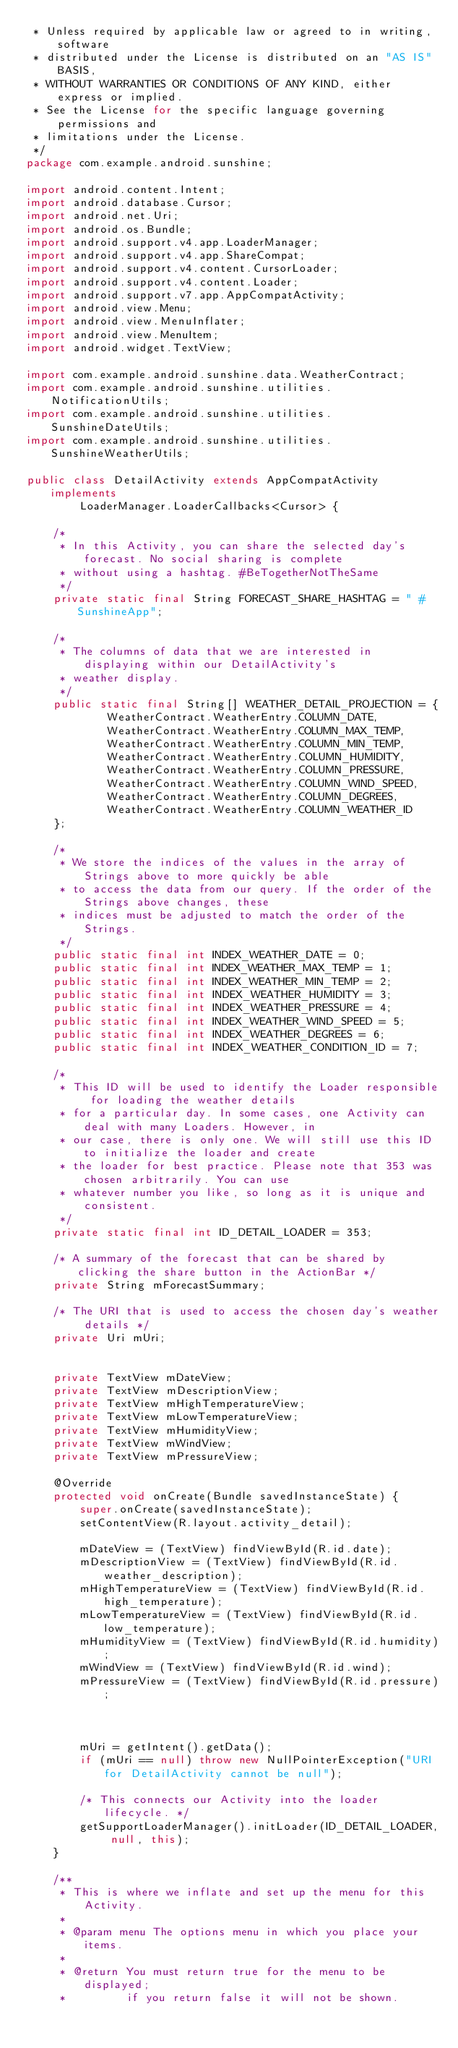<code> <loc_0><loc_0><loc_500><loc_500><_Java_> * Unless required by applicable law or agreed to in writing, software
 * distributed under the License is distributed on an "AS IS" BASIS,
 * WITHOUT WARRANTIES OR CONDITIONS OF ANY KIND, either express or implied.
 * See the License for the specific language governing permissions and
 * limitations under the License.
 */
package com.example.android.sunshine;

import android.content.Intent;
import android.database.Cursor;
import android.net.Uri;
import android.os.Bundle;
import android.support.v4.app.LoaderManager;
import android.support.v4.app.ShareCompat;
import android.support.v4.content.CursorLoader;
import android.support.v4.content.Loader;
import android.support.v7.app.AppCompatActivity;
import android.view.Menu;
import android.view.MenuInflater;
import android.view.MenuItem;
import android.widget.TextView;

import com.example.android.sunshine.data.WeatherContract;
import com.example.android.sunshine.utilities.NotificationUtils;
import com.example.android.sunshine.utilities.SunshineDateUtils;
import com.example.android.sunshine.utilities.SunshineWeatherUtils;

public class DetailActivity extends AppCompatActivity implements
        LoaderManager.LoaderCallbacks<Cursor> {

    /*
     * In this Activity, you can share the selected day's forecast. No social sharing is complete
     * without using a hashtag. #BeTogetherNotTheSame
     */
    private static final String FORECAST_SHARE_HASHTAG = " #SunshineApp";

    /*
     * The columns of data that we are interested in displaying within our DetailActivity's
     * weather display.
     */
    public static final String[] WEATHER_DETAIL_PROJECTION = {
            WeatherContract.WeatherEntry.COLUMN_DATE,
            WeatherContract.WeatherEntry.COLUMN_MAX_TEMP,
            WeatherContract.WeatherEntry.COLUMN_MIN_TEMP,
            WeatherContract.WeatherEntry.COLUMN_HUMIDITY,
            WeatherContract.WeatherEntry.COLUMN_PRESSURE,
            WeatherContract.WeatherEntry.COLUMN_WIND_SPEED,
            WeatherContract.WeatherEntry.COLUMN_DEGREES,
            WeatherContract.WeatherEntry.COLUMN_WEATHER_ID
    };

    /*
     * We store the indices of the values in the array of Strings above to more quickly be able
     * to access the data from our query. If the order of the Strings above changes, these
     * indices must be adjusted to match the order of the Strings.
     */
    public static final int INDEX_WEATHER_DATE = 0;
    public static final int INDEX_WEATHER_MAX_TEMP = 1;
    public static final int INDEX_WEATHER_MIN_TEMP = 2;
    public static final int INDEX_WEATHER_HUMIDITY = 3;
    public static final int INDEX_WEATHER_PRESSURE = 4;
    public static final int INDEX_WEATHER_WIND_SPEED = 5;
    public static final int INDEX_WEATHER_DEGREES = 6;
    public static final int INDEX_WEATHER_CONDITION_ID = 7;

    /*
     * This ID will be used to identify the Loader responsible for loading the weather details
     * for a particular day. In some cases, one Activity can deal with many Loaders. However, in
     * our case, there is only one. We will still use this ID to initialize the loader and create
     * the loader for best practice. Please note that 353 was chosen arbitrarily. You can use
     * whatever number you like, so long as it is unique and consistent.
     */
    private static final int ID_DETAIL_LOADER = 353;

    /* A summary of the forecast that can be shared by clicking the share button in the ActionBar */
    private String mForecastSummary;

    /* The URI that is used to access the chosen day's weather details */
    private Uri mUri;


    private TextView mDateView;
    private TextView mDescriptionView;
    private TextView mHighTemperatureView;
    private TextView mLowTemperatureView;
    private TextView mHumidityView;
    private TextView mWindView;
    private TextView mPressureView;

    @Override
    protected void onCreate(Bundle savedInstanceState) {
        super.onCreate(savedInstanceState);
        setContentView(R.layout.activity_detail);

        mDateView = (TextView) findViewById(R.id.date);
        mDescriptionView = (TextView) findViewById(R.id.weather_description);
        mHighTemperatureView = (TextView) findViewById(R.id.high_temperature);
        mLowTemperatureView = (TextView) findViewById(R.id.low_temperature);
        mHumidityView = (TextView) findViewById(R.id.humidity);
        mWindView = (TextView) findViewById(R.id.wind);
        mPressureView = (TextView) findViewById(R.id.pressure);



        mUri = getIntent().getData();
        if (mUri == null) throw new NullPointerException("URI for DetailActivity cannot be null");

        /* This connects our Activity into the loader lifecycle. */
        getSupportLoaderManager().initLoader(ID_DETAIL_LOADER, null, this);
    }

    /**
     * This is where we inflate and set up the menu for this Activity.
     *
     * @param menu The options menu in which you place your items.
     *
     * @return You must return true for the menu to be displayed;
     *         if you return false it will not be shown.</code> 